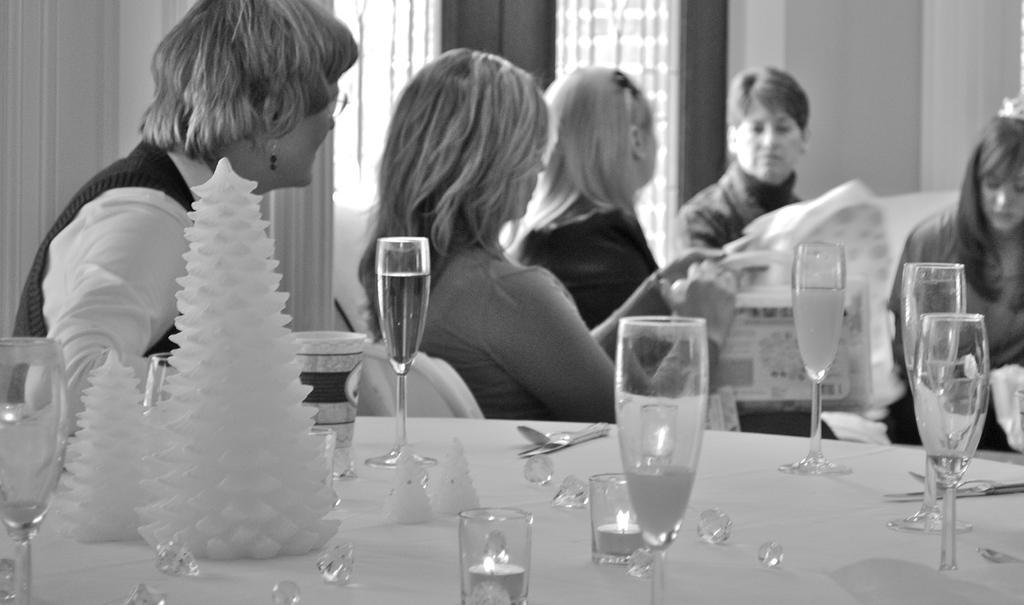How would you summarize this image in a sentence or two? There are many ladies sitting. In the front there is table. On the table there are glasses, candles in glasses, some decorative items. In the background there are curtains, windows. 